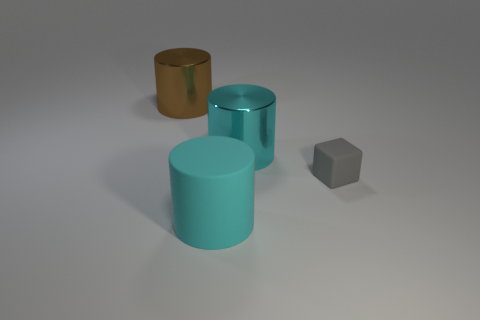Add 1 cyan metal cylinders. How many objects exist? 5 Subtract all cylinders. How many objects are left? 1 Subtract all yellow rubber balls. Subtract all big cylinders. How many objects are left? 1 Add 4 big brown cylinders. How many big brown cylinders are left? 5 Add 3 red spheres. How many red spheres exist? 3 Subtract 0 blue cylinders. How many objects are left? 4 